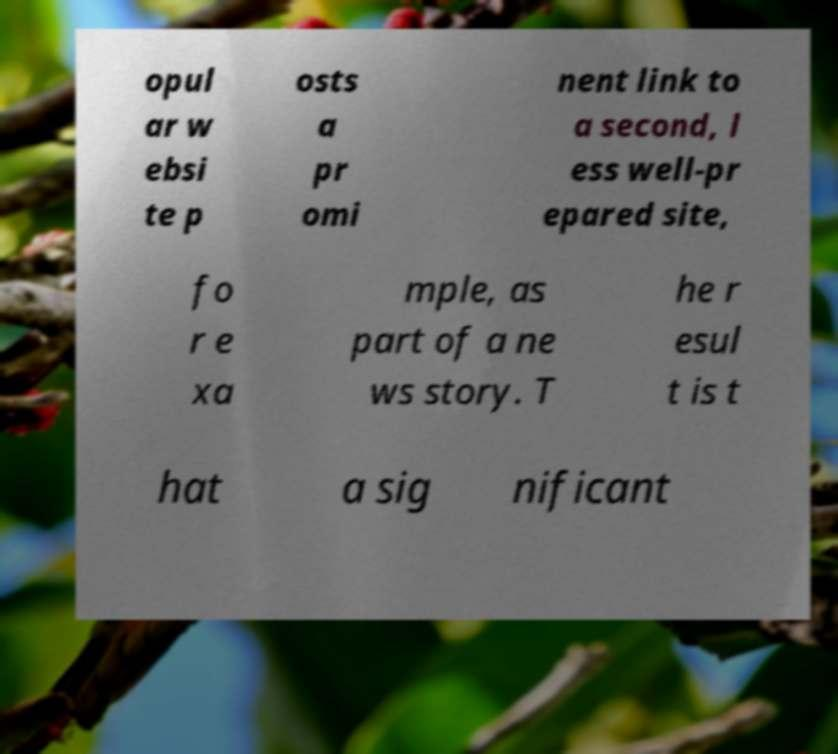What messages or text are displayed in this image? I need them in a readable, typed format. opul ar w ebsi te p osts a pr omi nent link to a second, l ess well-pr epared site, fo r e xa mple, as part of a ne ws story. T he r esul t is t hat a sig nificant 